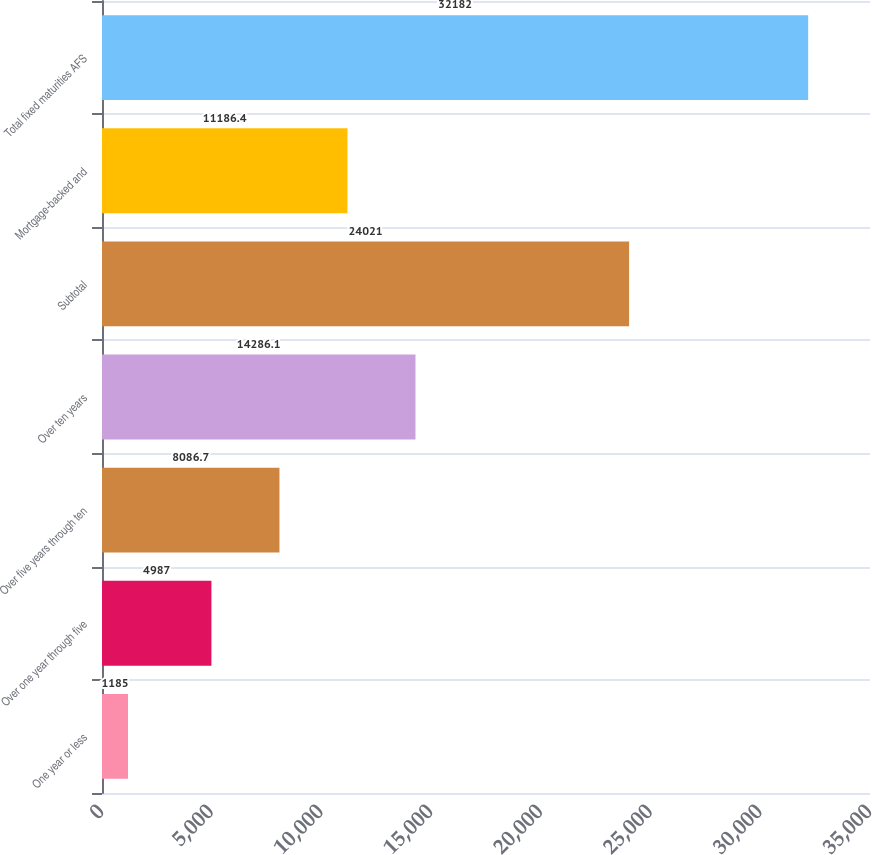Convert chart to OTSL. <chart><loc_0><loc_0><loc_500><loc_500><bar_chart><fcel>One year or less<fcel>Over one year through five<fcel>Over five years through ten<fcel>Over ten years<fcel>Subtotal<fcel>Mortgage-backed and<fcel>Total fixed maturities AFS<nl><fcel>1185<fcel>4987<fcel>8086.7<fcel>14286.1<fcel>24021<fcel>11186.4<fcel>32182<nl></chart> 